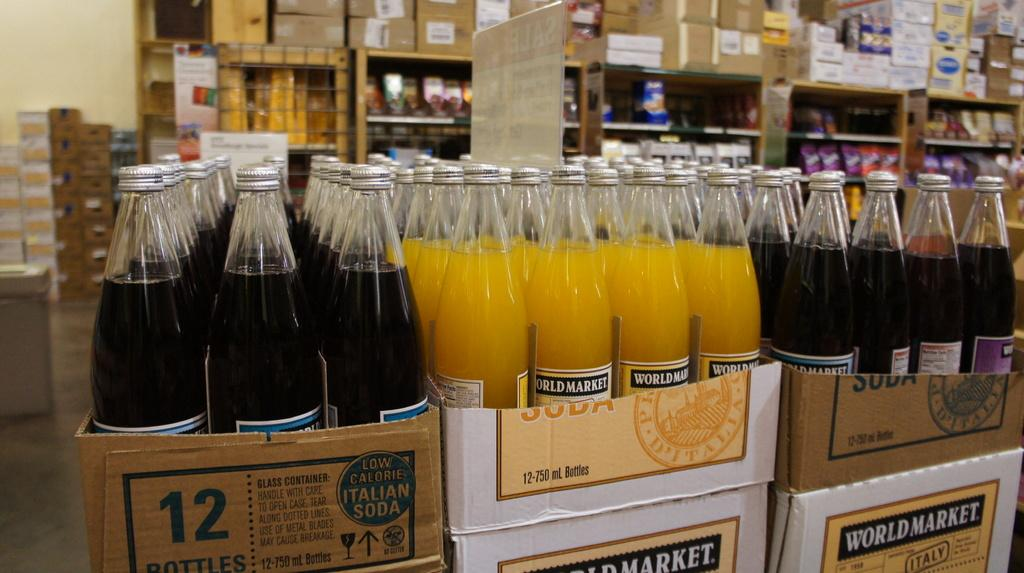<image>
Describe the image concisely. Cases of what appear to be bottled sodas on a World market shelf 